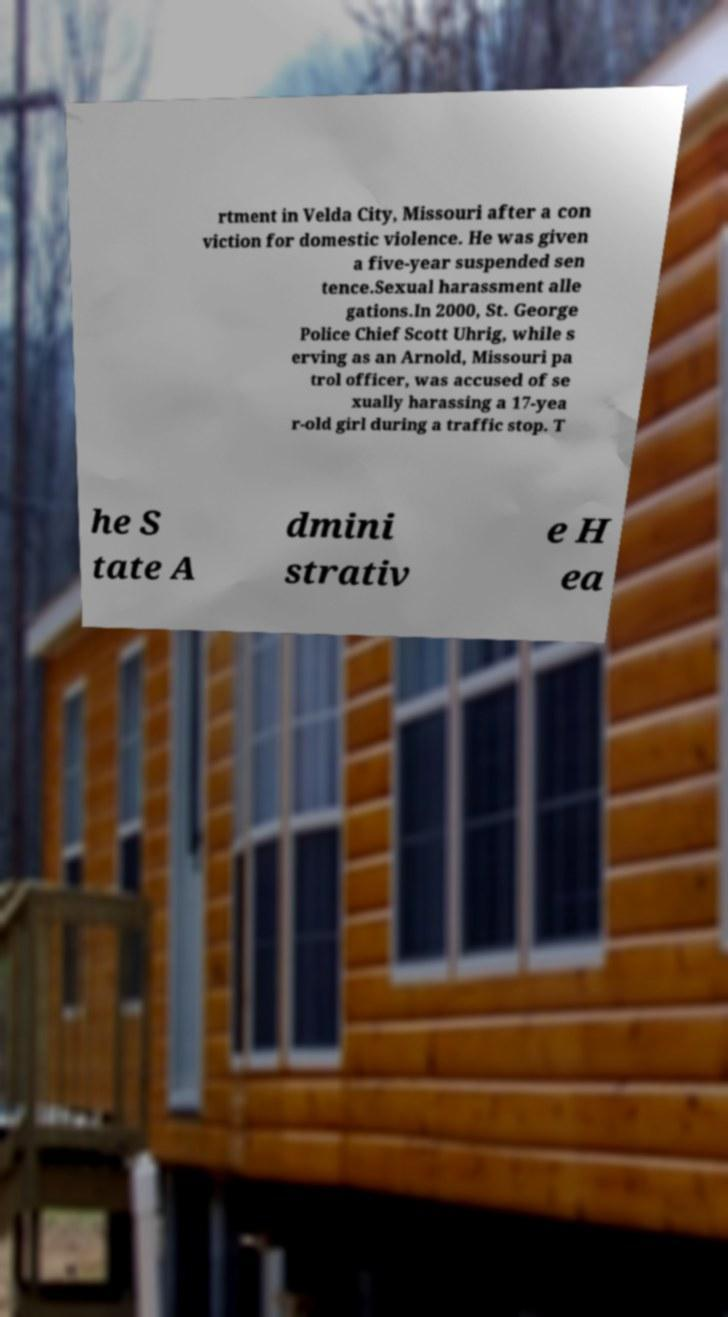Please identify and transcribe the text found in this image. rtment in Velda City, Missouri after a con viction for domestic violence. He was given a five-year suspended sen tence.Sexual harassment alle gations.In 2000, St. George Police Chief Scott Uhrig, while s erving as an Arnold, Missouri pa trol officer, was accused of se xually harassing a 17-yea r-old girl during a traffic stop. T he S tate A dmini strativ e H ea 